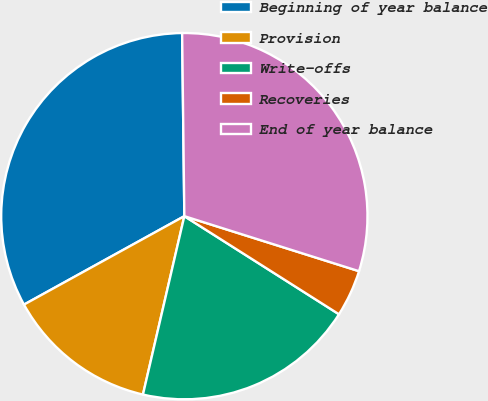Convert chart. <chart><loc_0><loc_0><loc_500><loc_500><pie_chart><fcel>Beginning of year balance<fcel>Provision<fcel>Write-offs<fcel>Recoveries<fcel>End of year balance<nl><fcel>32.83%<fcel>13.35%<fcel>19.63%<fcel>4.14%<fcel>30.05%<nl></chart> 